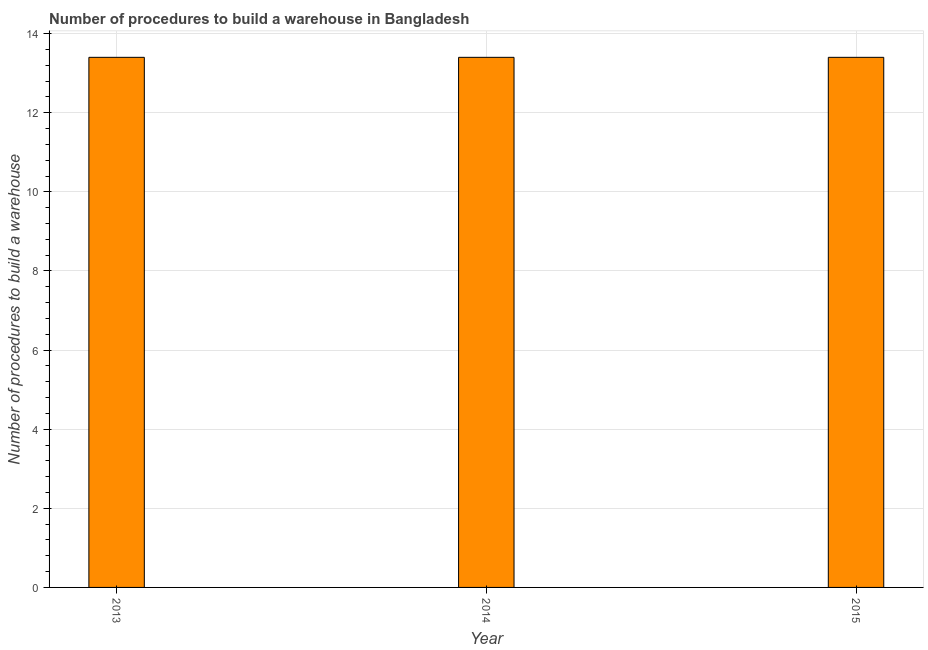Does the graph contain grids?
Provide a short and direct response. Yes. What is the title of the graph?
Your answer should be compact. Number of procedures to build a warehouse in Bangladesh. What is the label or title of the Y-axis?
Offer a terse response. Number of procedures to build a warehouse. Across all years, what is the maximum number of procedures to build a warehouse?
Ensure brevity in your answer.  13.4. Across all years, what is the minimum number of procedures to build a warehouse?
Your answer should be compact. 13.4. In which year was the number of procedures to build a warehouse maximum?
Your answer should be very brief. 2013. What is the sum of the number of procedures to build a warehouse?
Keep it short and to the point. 40.2. What is the difference between the number of procedures to build a warehouse in 2013 and 2014?
Provide a succinct answer. 0. What is the median number of procedures to build a warehouse?
Give a very brief answer. 13.4. In how many years, is the number of procedures to build a warehouse greater than 10.8 ?
Your answer should be very brief. 3. Do a majority of the years between 2015 and 2013 (inclusive) have number of procedures to build a warehouse greater than 2.8 ?
Your answer should be compact. Yes. What is the ratio of the number of procedures to build a warehouse in 2013 to that in 2015?
Provide a short and direct response. 1. Is the difference between the number of procedures to build a warehouse in 2013 and 2015 greater than the difference between any two years?
Your response must be concise. Yes. What is the difference between the highest and the second highest number of procedures to build a warehouse?
Offer a terse response. 0. Is the sum of the number of procedures to build a warehouse in 2013 and 2015 greater than the maximum number of procedures to build a warehouse across all years?
Your answer should be compact. Yes. What is the difference between the highest and the lowest number of procedures to build a warehouse?
Give a very brief answer. 0. How many years are there in the graph?
Offer a very short reply. 3. What is the difference between the Number of procedures to build a warehouse in 2013 and 2014?
Your answer should be compact. 0. What is the difference between the Number of procedures to build a warehouse in 2014 and 2015?
Your answer should be compact. 0. What is the ratio of the Number of procedures to build a warehouse in 2013 to that in 2015?
Your response must be concise. 1. 